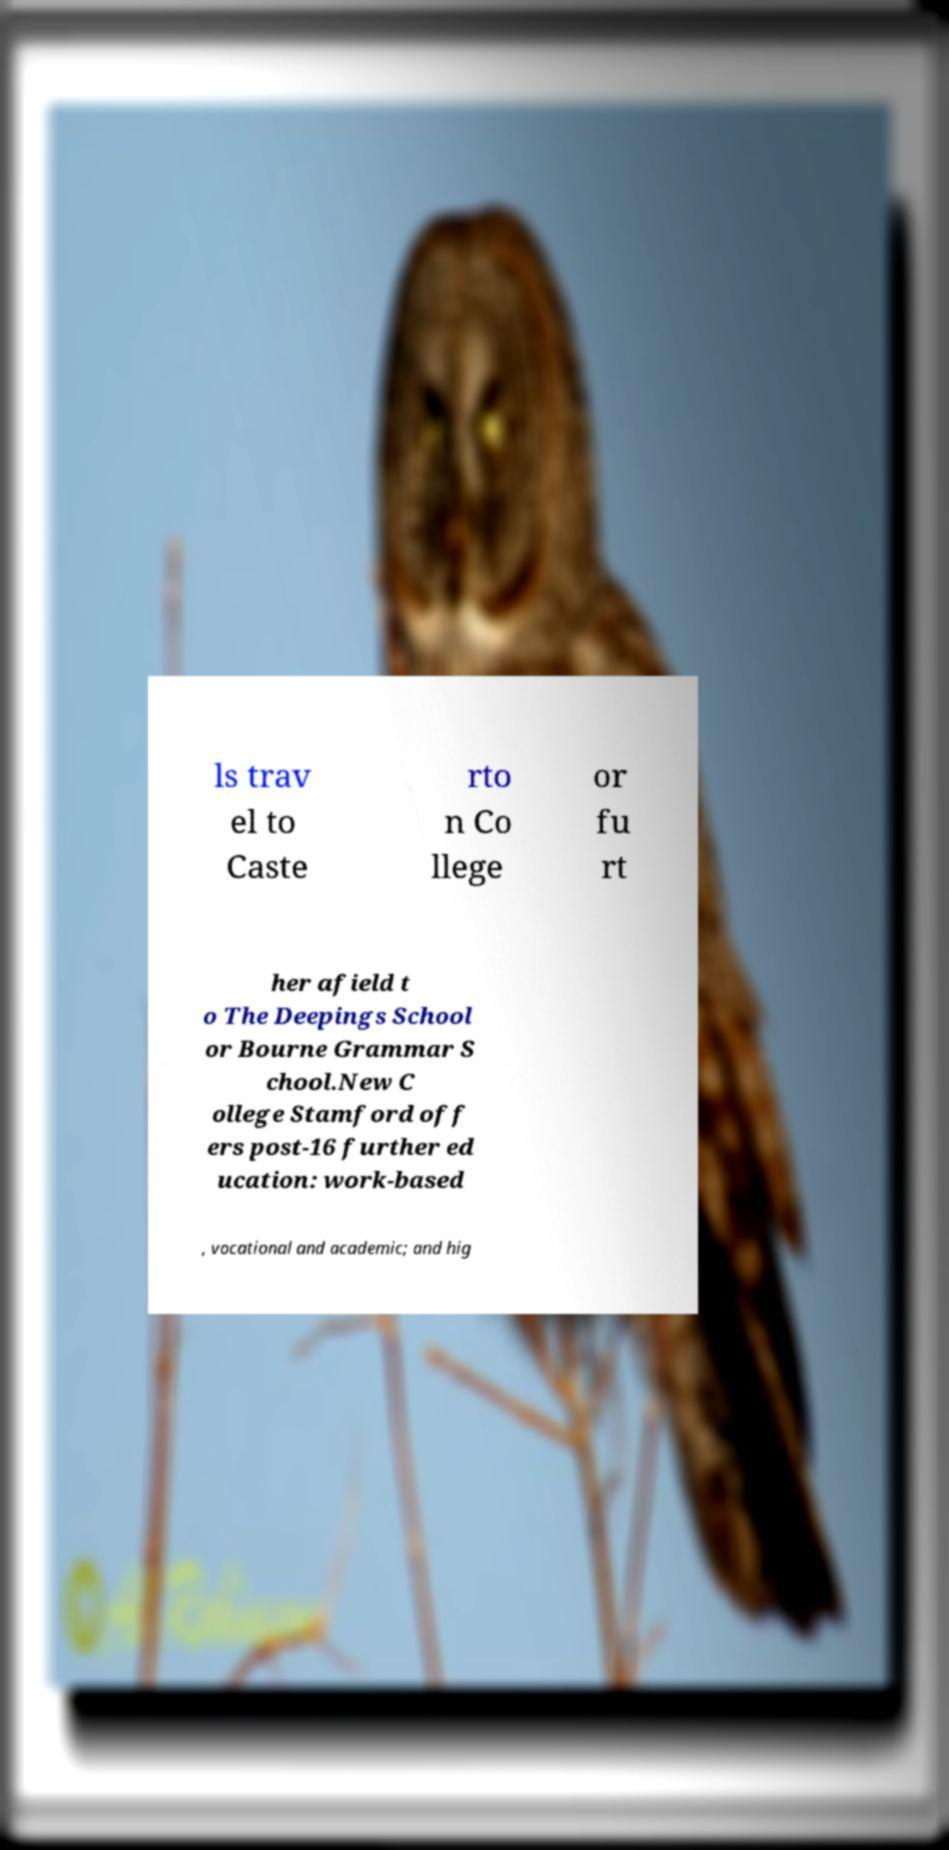Please identify and transcribe the text found in this image. ls trav el to Caste rto n Co llege or fu rt her afield t o The Deepings School or Bourne Grammar S chool.New C ollege Stamford off ers post-16 further ed ucation: work-based , vocational and academic; and hig 